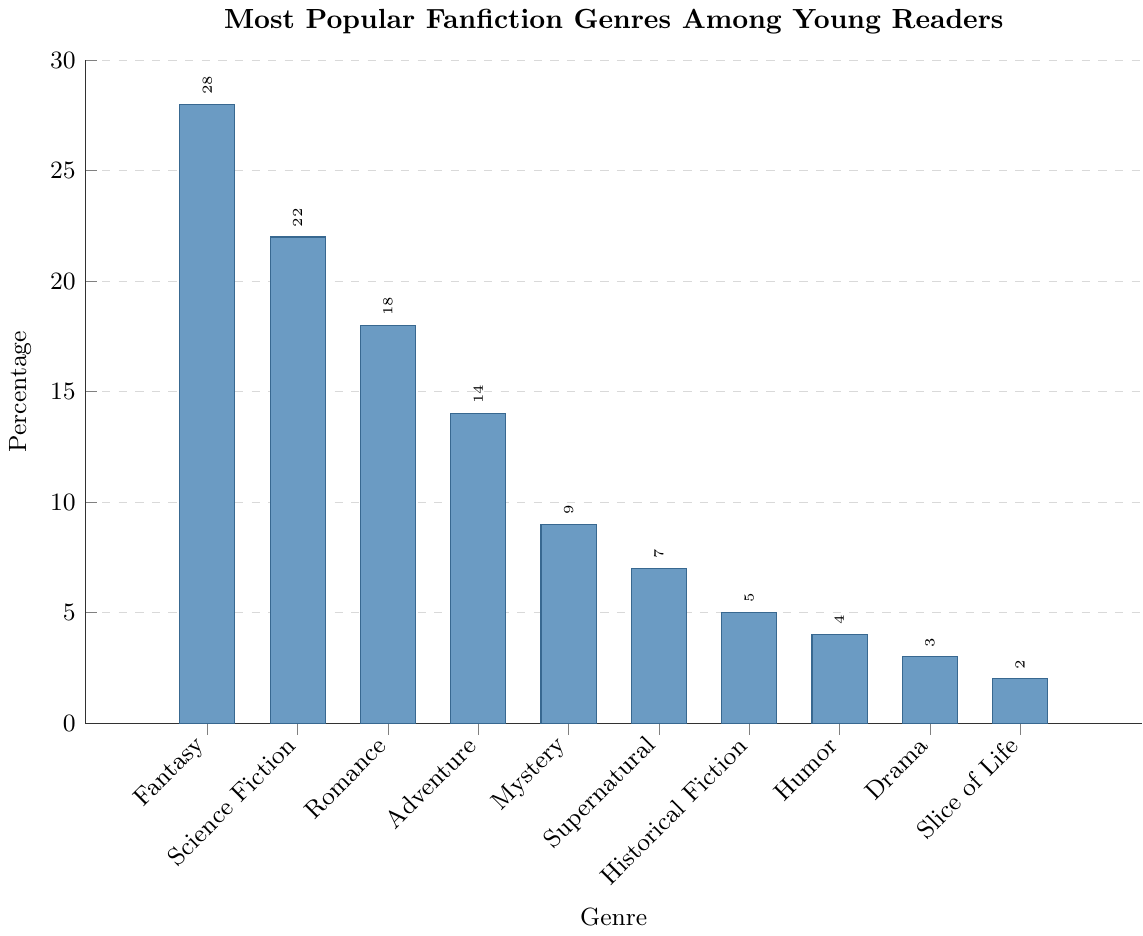Which genre has the highest percentage among young readers? The genre with the tallest bar represents the highest percentage. In this case, Fantasy has the tallest bar.
Answer: Fantasy What is the combined percentage of Fantasy and Science Fiction genres? The percentages for Fantasy and Science Fiction are 28% and 22%, respectively. Adding them together, 28 + 22 = 50.
Answer: 50 Which genres have a percentage lower than 10%? The bars for Mystery, Supernatural, Historical Fiction, Humor, Drama, and Slice of Life are below the 10% mark.
Answer: Mystery, Supernatural, Historical Fiction, Humor, Drama, Slice of Life How much more popular is Fantasy than Romance in percentage terms? The percentage for Fantasy is 28%, and for Romance, it is 18%. Subtracting the percentages, 28 - 18 = 10.
Answer: 10 Arrange the genres in descending order of their percentages. Listing the genres from the tallest bar to the shortest bar: Fantasy, Science Fiction, Romance, Adventure, Mystery, Supernatural, Historical Fiction, Humor, Drama, Slice of Life.
Answer: Fantasy, Science Fiction, Romance, Adventure, Mystery, Supernatural, Historical Fiction, Humor, Drama, Slice of Life What is the average percentage of the top three genres? The percentages for the top three genres are Fantasy (28%), Science Fiction (22%), and Romance (18%). Sum these percentages and divide by three: (28 + 22 + 18) / 3 = 68 / 3 = 22.67.
Answer: 22.67 Is Supernatural more popular than Historical Fiction? By comparing their heights, Supernatural has a percentage of 7%, while Historical Fiction has a percentage of 5%. Since 7 > 5, Supernatural is more popular.
Answer: Yes What percentage of young readers prefer genres other than Fantasy? The total percentage is 100%. By subtracting Fantasy’s percentage (28%), we get 100 - 28 = 72.
Answer: 72 How do the combined percentages of Adventure and Mystery compare with Science Fiction? Adventure has 14% and Mystery has 9%. Adding them, 14 + 9 = 23. Science Fiction has 22%, so 23 > 22, meaning the combined percentage is higher.
Answer: Higher What is the percentage range among the genres? The highest percentage is for Fantasy (28%) and the lowest is for Slice of Life (2%). The range is found by subtracting the lowest percentage from the highest: 28 - 2 = 26.
Answer: 26 